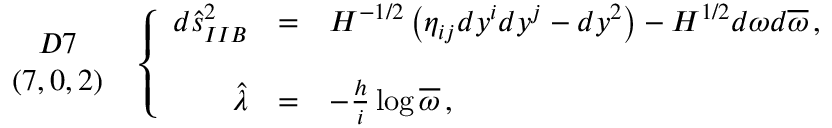Convert formula to latex. <formula><loc_0><loc_0><loc_500><loc_500>\begin{array} { c } { D 7 } \\ { ( 7 , 0 , 2 ) } \end{array} \, \left \{ \begin{array} { r c l } { { d \hat { s } _ { I I B } ^ { 2 } } } & { = } & { { H ^ { - 1 / 2 } \left ( \eta _ { i j } d y ^ { i } d y ^ { j } - d y ^ { 2 } \right ) - H ^ { 1 / 2 } d \omega d \overline { \omega } \, , } } \\ { { \hat { \lambda } } } & { = } & { { - \frac { h } { i } \log { \overline { \omega } } \, , } } \end{array}</formula> 